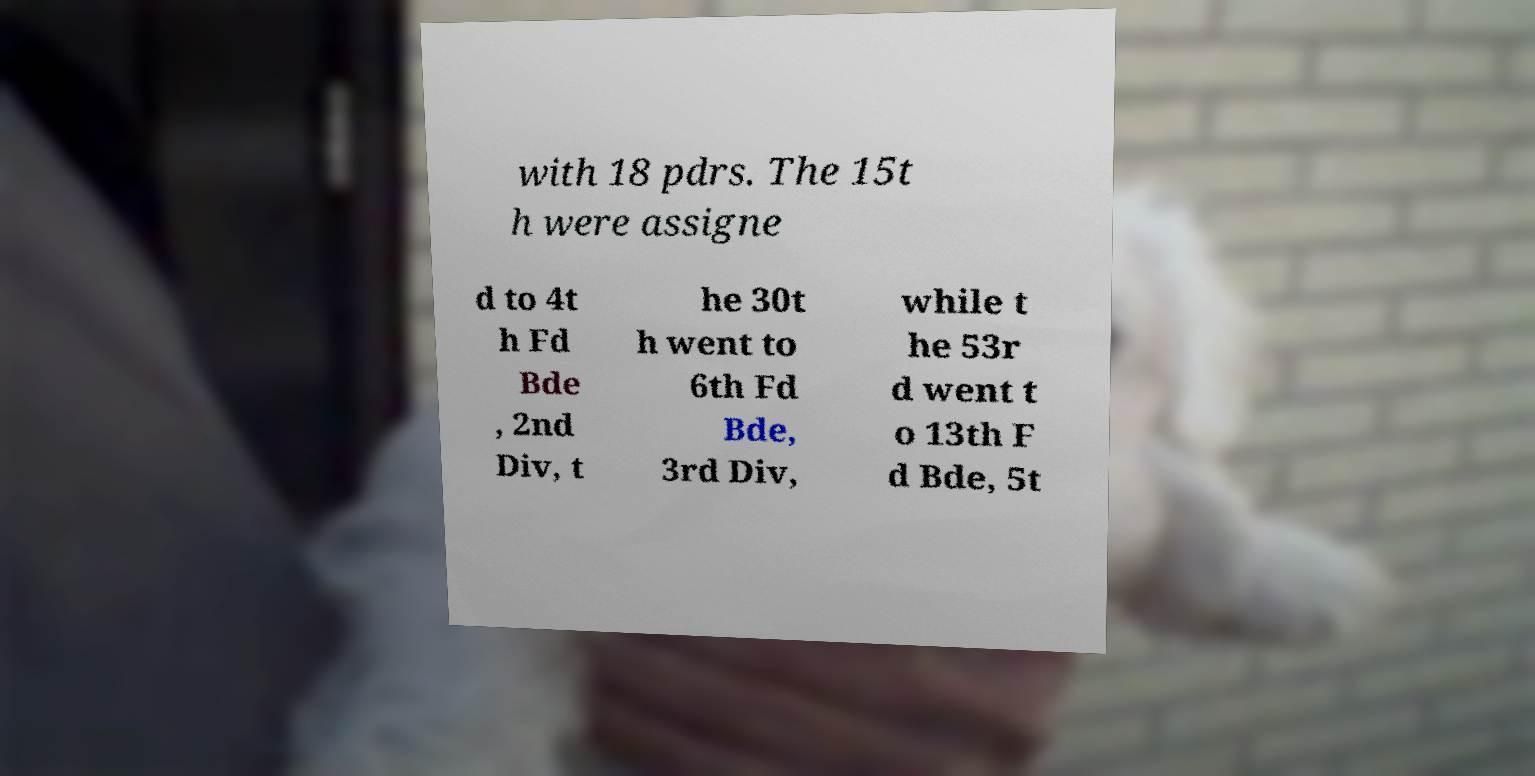I need the written content from this picture converted into text. Can you do that? with 18 pdrs. The 15t h were assigne d to 4t h Fd Bde , 2nd Div, t he 30t h went to 6th Fd Bde, 3rd Div, while t he 53r d went t o 13th F d Bde, 5t 